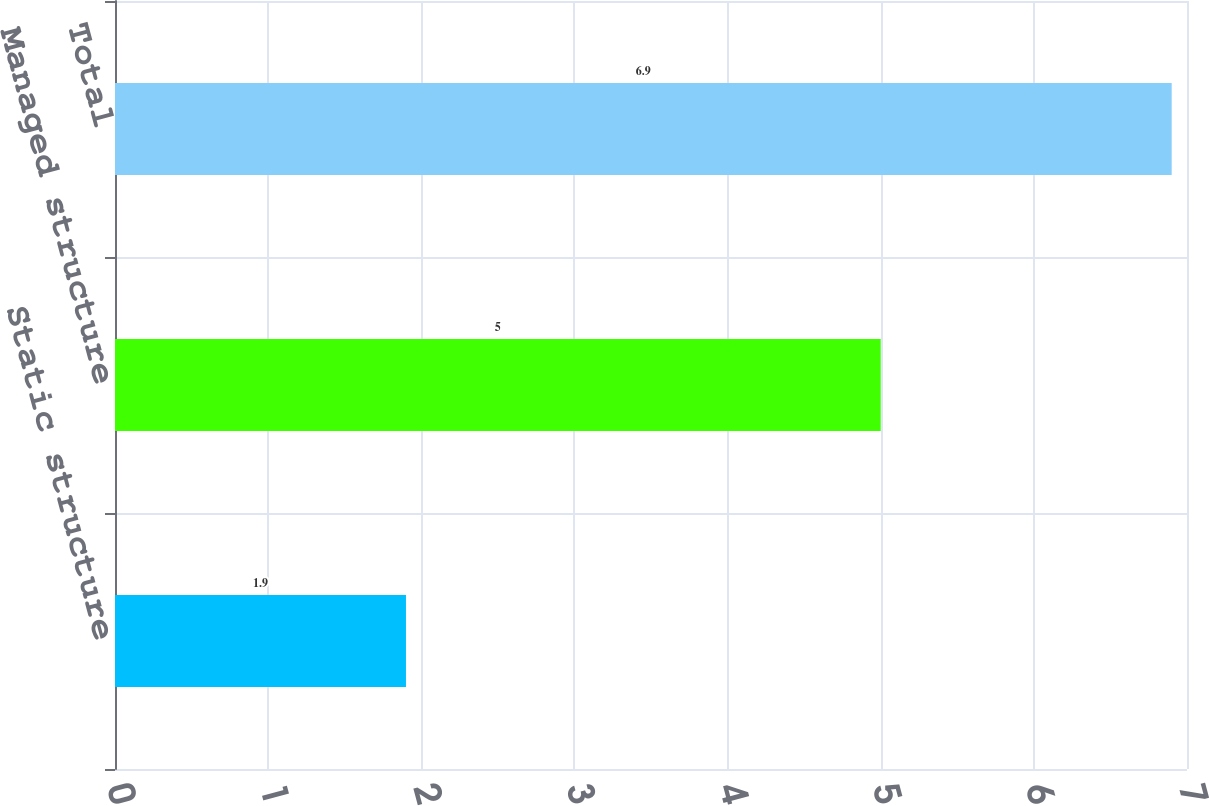<chart> <loc_0><loc_0><loc_500><loc_500><bar_chart><fcel>Static structure<fcel>Managed structure<fcel>Total<nl><fcel>1.9<fcel>5<fcel>6.9<nl></chart> 